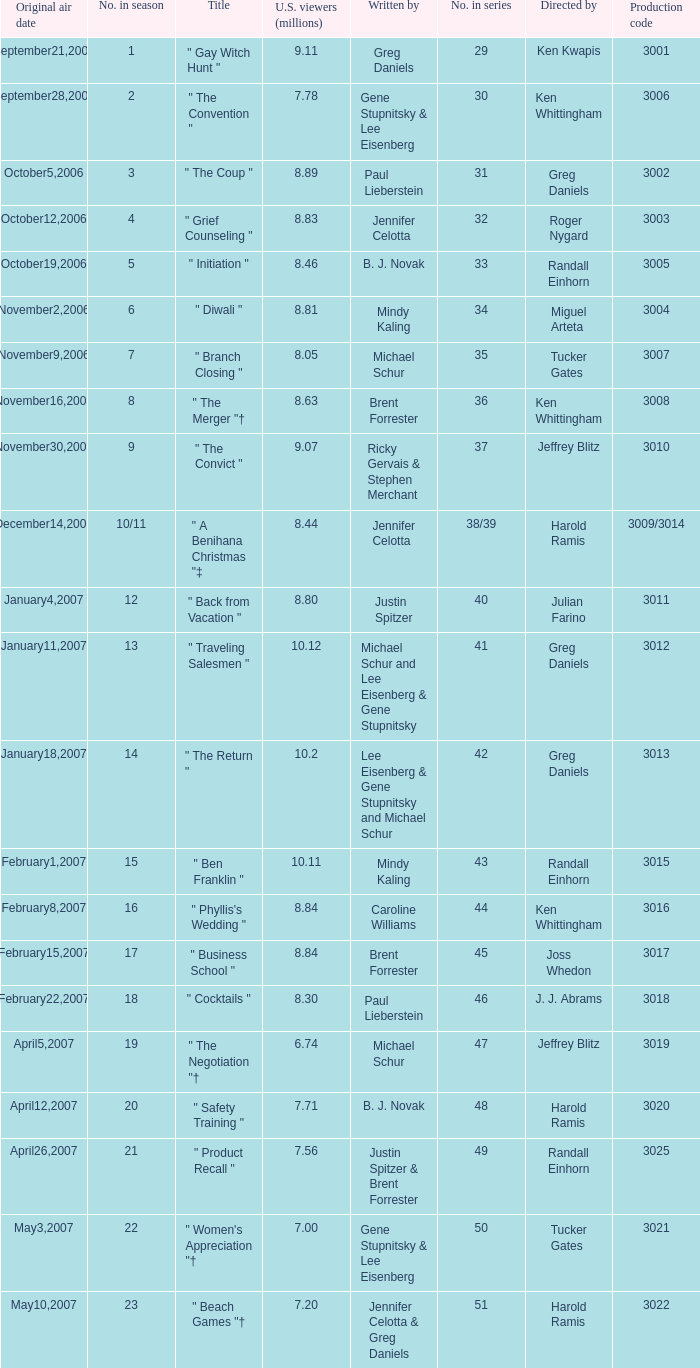Name the total number of titles for 3020 production code 1.0. 